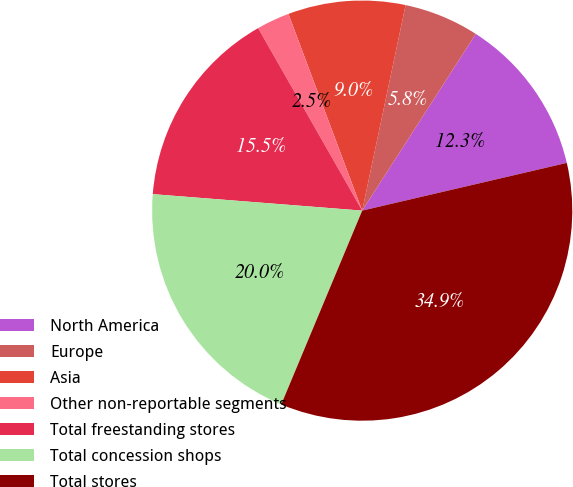Convert chart to OTSL. <chart><loc_0><loc_0><loc_500><loc_500><pie_chart><fcel>North America<fcel>Europe<fcel>Asia<fcel>Other non-reportable segments<fcel>Total freestanding stores<fcel>Total concession shops<fcel>Total stores<nl><fcel>12.26%<fcel>5.78%<fcel>9.02%<fcel>2.54%<fcel>15.5%<fcel>19.95%<fcel>34.94%<nl></chart> 